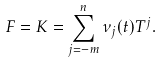Convert formula to latex. <formula><loc_0><loc_0><loc_500><loc_500>F = K = \sum _ { j = - m } ^ { n } \nu _ { j } ( t ) T ^ { j } .</formula> 